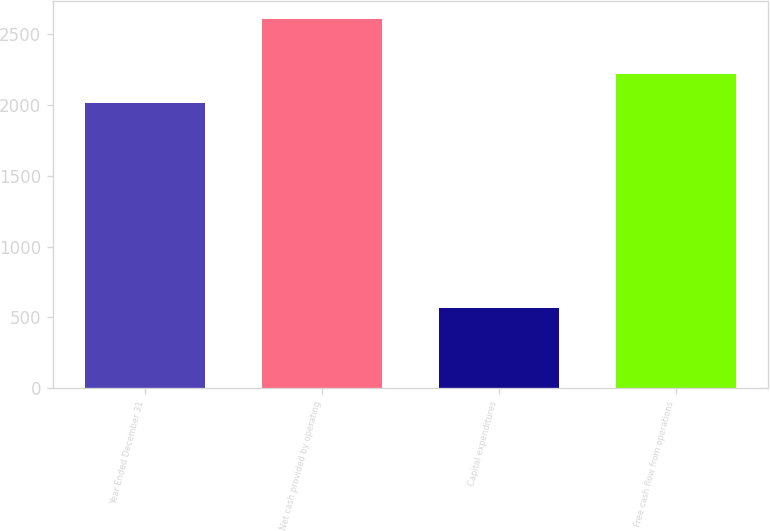Convert chart. <chart><loc_0><loc_0><loc_500><loc_500><bar_chart><fcel>Year Ended December 31<fcel>Net cash provided by operating<fcel>Capital expenditures<fcel>Free cash flow from operations<nl><fcel>2015<fcel>2607<fcel>569<fcel>2218.8<nl></chart> 